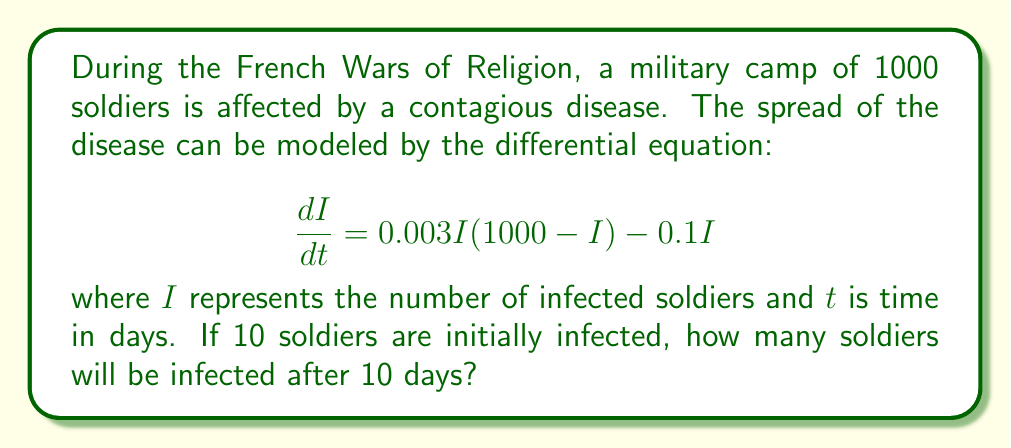Show me your answer to this math problem. To solve this problem, we need to use the given differential equation and initial condition:

1) The differential equation is in the form of a logistic growth model with an additional term for recovery:
   $$\frac{dI}{dt} = 0.003I(1000-I) - 0.1I$$

2) We can solve this numerically using Euler's method:
   $$I_{n+1} = I_n + \Delta t \cdot \frac{dI}{dt}$$

3) Let's use a step size $\Delta t = 0.1$ days. We'll need 100 steps to reach 10 days.

4) Initial condition: $I_0 = 10$

5) For each step, we calculate:
   $$I_{n+1} = I_n + 0.1 \cdot (0.003I_n(1000-I_n) - 0.1I_n)$$

6) We can implement this in a loop:

   ```
   I = 10
   for step in range(100):
       dIdt = 0.003 * I * (1000 - I) - 0.1 * I
       I = I + 0.1 * dIdt
   ```

7) After running this calculation, we find that $I \approx 309.8$ after 10 days.

8) Rounding to the nearest whole number, as we can't have fractional soldiers, we get 310 infected soldiers.
Answer: 310 soldiers 